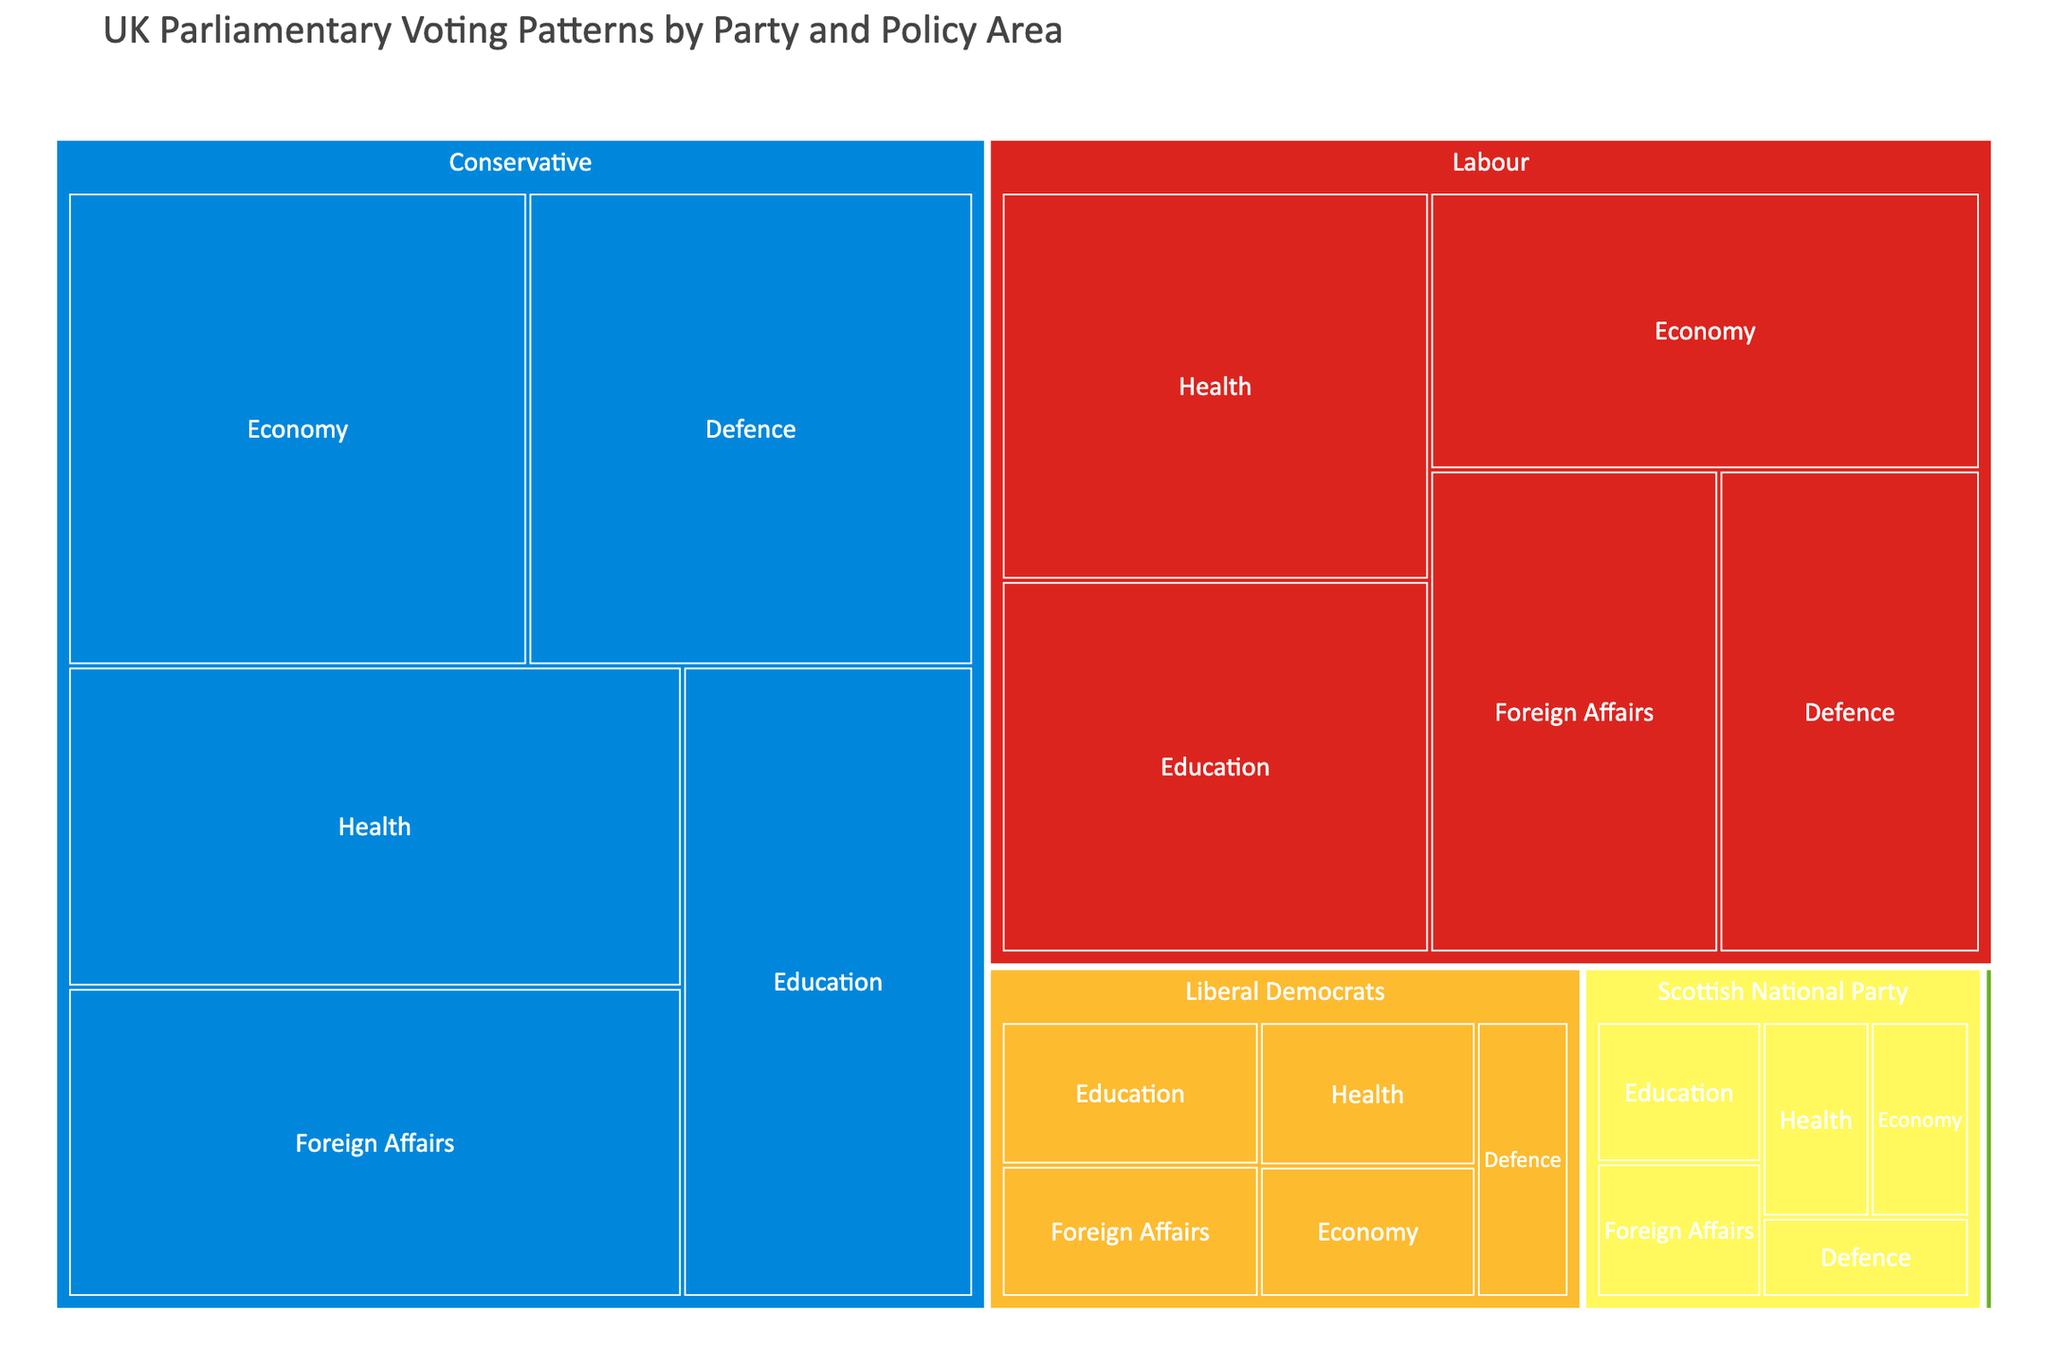How many total votes did the Labour Party cast? Look at the segments labelled "Labour" in each policy area, then sum up the votes: 230 (Economy) + 210 (Foreign Affairs) + 250 (Health) + 240 (Education) + 190 (Defence).
Answer: 1120 What policy area received the most votes from the Conservative Party? Check each policy area segment under the "Conservative" label and compare the votes: 320 (Economy), 280 (Foreign Affairs), 290 (Health), 270 (Education), 310 (Defence). Economy has the highest vote count.
Answer: Economy Which party cast the fewest votes in the Defence policy area? Compare the Defence segment votes for each party: Conservative (310), Labour (190), Liberal Democrats (45), Scottish National Party (30), Green Party (1). The fewest votes were cast by the Green Party.
Answer: Green Party How many total votes were cast in the Education policy area across all parties? Sum the votes in the Education segments for each party: Conservative (270), Labour (240), Liberal Democrats (65), Scottish National Party (42), Green Party (1).
Answer: 618 Which policy area did the Scottish National Party cast more votes in: Foreign Affairs or Health? Compare the votes in the Foreign Affairs and Health segments under the "Scottish National Party" label: 40 (Foreign Affairs), 38 (Health). Foreign Affairs has more votes.
Answer: Foreign Affairs What is the average number of votes for the Liberal Democrats across all policy areas? Sum up the votes in all policy area segments for Liberal Democrats: 50 (Economy) + 60 (Foreign Affairs) + 55 (Health) + 65 (Education) + 45 (Defence) = 275. Divide by the number of policy areas (5).
Answer: 55 Which party has the largest area in the Treemap? Observe the sections corresponding to each party and find the one occupying the most space: Compare Conservative, Labour, Liberal Democrats, Scottish National Party, and Green Party. Conservative has the largest area.
Answer: Conservative How many more votes did the Conservative Party cast in the Economy policy area compared to the Labour Party? Subtract Labour's votes from Conservative's votes in the Economy segment: 320 (Conservative) - 230 (Labour).
Answer: 90 What percentage of total votes in the Health policy area were cast by the Labour Party? Calculate total votes in Health by summing segments across all parties: Conservative (290) + Labour (250) + Liberal Democrats (55) + Scottish National Party (38) + Green Party (1) = 634. Then, compute Labour's percentage: (250 / 634) * 100.
Answer: ~39.43% Which party showed the least voting activity overall? Compare total votes of all parties by summing their respective votes in all policy areas. Green Party (5 votes in total) showed the least activity.
Answer: Green Party 